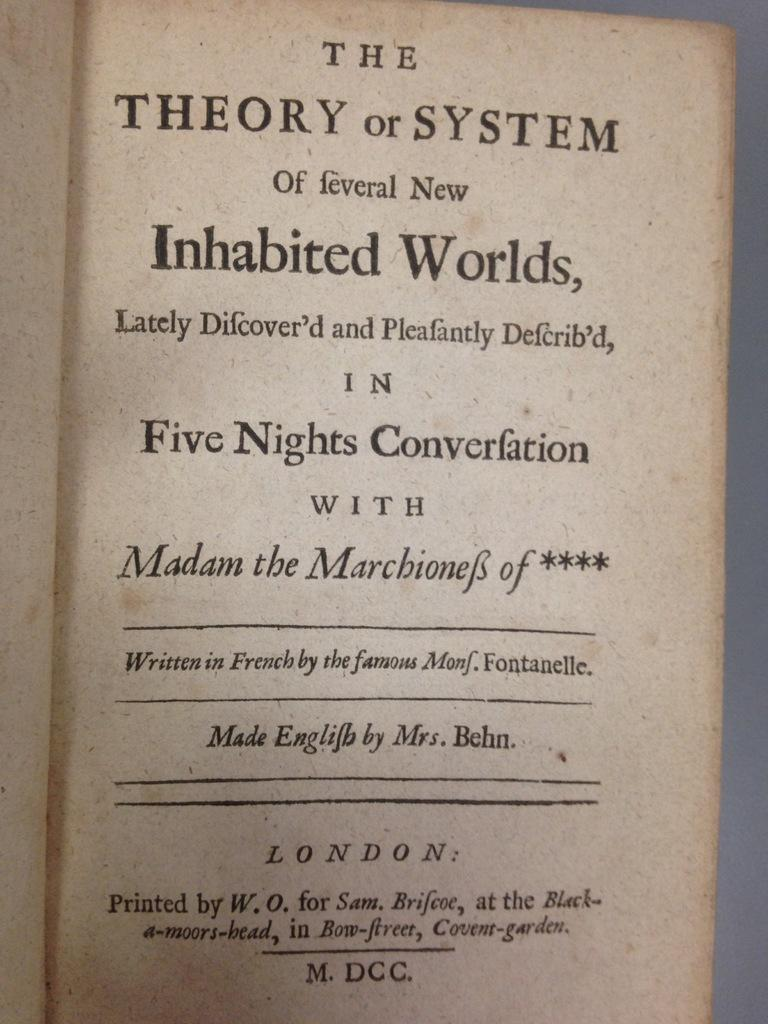<image>
Write a terse but informative summary of the picture. Vintage book written in French by the famous Monf. Fontanelle. 